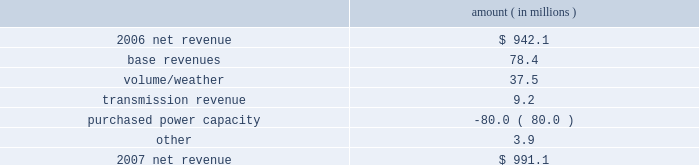Entergy louisiana , llc management's financial discussion and analysis 2007 compared to 2006 net revenue consists of operating revenues net of : 1 ) fuel , fuel-related expenses , and gas purchased for resale , 2 ) purchased power expenses , and 3 ) other regulatory charges ( credits ) .
Following is an analysis of the change in net revenue comparing 2007 to 2006 .
Amount ( in millions ) .
The base revenues variance is primarily due to increases effective september 2006 for the 2005 formula rate plan filing to recover lpsc-approved incremental deferred and ongoing capacity costs .
See "state and local rate regulation" below and note 2 to the financial statements for a discussion of the formula rate plan filing .
The volume/weather variance is due to increased electricity usage , including electricity sales during the unbilled service period .
Billed retail electricity usage increased a total of 666 gwh in all sectors compared to 2006 .
See "critical accounting estimates" below and note 1 to the financial statements for further discussion of the accounting for unbilled revenues .
The transmission revenue variance is primarily due to higher rates .
The purchased power capacity variance is primarily due to higher purchased power capacity charges and the amortization of capacity charges effective september 2006 as a result of the formula rate plan filing in may 2006 .
A portion of the purchased power capacity costs is offset in base revenues due to a base rate increase implemented to recover incremental deferred and ongoing purchased power capacity charges , as mentioned above .
See "state and local rate regulation" below and note 2 to the financial statements for a discussion of the formula rate plan filing .
Gross operating revenues , fuel , purchased power expenses , and other regulatory charges ( credits ) gross operating revenues increased primarily due to : an increase of $ 143.1 million in fuel cost recovery revenues due to higher fuel rates and usage ; an increase of $ 78.4 million in base revenues , as discussed above ; and an increase of $ 37.5 million related to volume/weather , as discussed above .
Fuel and purchased power expenses increased primarily due to an increase in net area demand and an increase in deferred fuel expense as a result of higher fuel rates , as discussed above .
Other regulatory credits decreased primarily due to the deferral of capacity charges in 2006 in addition to the amortization of these capacity charges in 2007 as a result of the may 2006 formula rate plan filing ( for the 2005 test year ) with the lpsc to recover such costs through base rates effective september 2006 .
See note 2 to the financial statements for a discussion of the formula rate plan and storm cost recovery filings with the lpsc. .
What is the growth rate in net revenue in 2007? 
Computations: ((991.1 - 942.1) / 942.1)
Answer: 0.05201. 